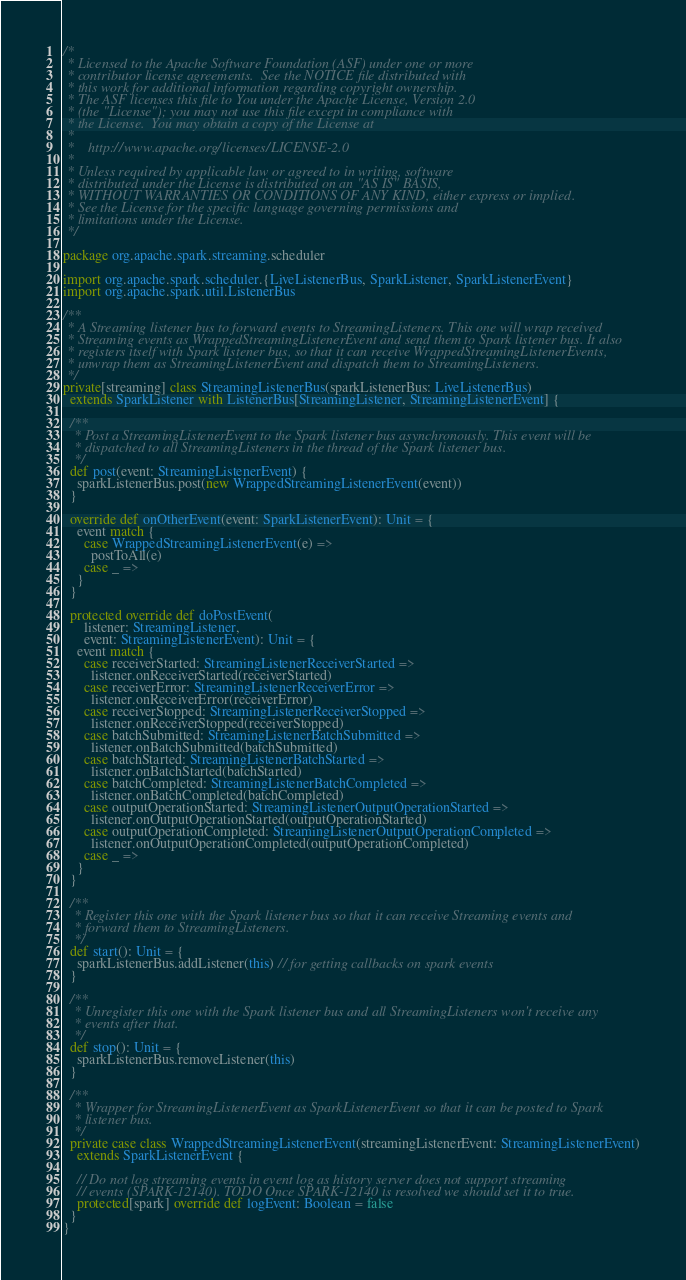Convert code to text. <code><loc_0><loc_0><loc_500><loc_500><_Scala_>/*
 * Licensed to the Apache Software Foundation (ASF) under one or more
 * contributor license agreements.  See the NOTICE file distributed with
 * this work for additional information regarding copyright ownership.
 * The ASF licenses this file to You under the Apache License, Version 2.0
 * (the "License"); you may not use this file except in compliance with
 * the License.  You may obtain a copy of the License at
 *
 *    http://www.apache.org/licenses/LICENSE-2.0
 *
 * Unless required by applicable law or agreed to in writing, software
 * distributed under the License is distributed on an "AS IS" BASIS,
 * WITHOUT WARRANTIES OR CONDITIONS OF ANY KIND, either express or implied.
 * See the License for the specific language governing permissions and
 * limitations under the License.
 */

package org.apache.spark.streaming.scheduler

import org.apache.spark.scheduler.{LiveListenerBus, SparkListener, SparkListenerEvent}
import org.apache.spark.util.ListenerBus

/**
 * A Streaming listener bus to forward events to StreamingListeners. This one will wrap received
 * Streaming events as WrappedStreamingListenerEvent and send them to Spark listener bus. It also
 * registers itself with Spark listener bus, so that it can receive WrappedStreamingListenerEvents,
 * unwrap them as StreamingListenerEvent and dispatch them to StreamingListeners.
 */
private[streaming] class StreamingListenerBus(sparkListenerBus: LiveListenerBus)
  extends SparkListener with ListenerBus[StreamingListener, StreamingListenerEvent] {

  /**
   * Post a StreamingListenerEvent to the Spark listener bus asynchronously. This event will be
   * dispatched to all StreamingListeners in the thread of the Spark listener bus.
   */
  def post(event: StreamingListenerEvent) {
    sparkListenerBus.post(new WrappedStreamingListenerEvent(event))
  }

  override def onOtherEvent(event: SparkListenerEvent): Unit = {
    event match {
      case WrappedStreamingListenerEvent(e) =>
        postToAll(e)
      case _ =>
    }
  }

  protected override def doPostEvent(
      listener: StreamingListener,
      event: StreamingListenerEvent): Unit = {
    event match {
      case receiverStarted: StreamingListenerReceiverStarted =>
        listener.onReceiverStarted(receiverStarted)
      case receiverError: StreamingListenerReceiverError =>
        listener.onReceiverError(receiverError)
      case receiverStopped: StreamingListenerReceiverStopped =>
        listener.onReceiverStopped(receiverStopped)
      case batchSubmitted: StreamingListenerBatchSubmitted =>
        listener.onBatchSubmitted(batchSubmitted)
      case batchStarted: StreamingListenerBatchStarted =>
        listener.onBatchStarted(batchStarted)
      case batchCompleted: StreamingListenerBatchCompleted =>
        listener.onBatchCompleted(batchCompleted)
      case outputOperationStarted: StreamingListenerOutputOperationStarted =>
        listener.onOutputOperationStarted(outputOperationStarted)
      case outputOperationCompleted: StreamingListenerOutputOperationCompleted =>
        listener.onOutputOperationCompleted(outputOperationCompleted)
      case _ =>
    }
  }

  /**
   * Register this one with the Spark listener bus so that it can receive Streaming events and
   * forward them to StreamingListeners.
   */
  def start(): Unit = {
    sparkListenerBus.addListener(this) // for getting callbacks on spark events
  }

  /**
   * Unregister this one with the Spark listener bus and all StreamingListeners won't receive any
   * events after that.
   */
  def stop(): Unit = {
    sparkListenerBus.removeListener(this)
  }

  /**
   * Wrapper for StreamingListenerEvent as SparkListenerEvent so that it can be posted to Spark
   * listener bus.
   */
  private case class WrappedStreamingListenerEvent(streamingListenerEvent: StreamingListenerEvent)
    extends SparkListenerEvent {

    // Do not log streaming events in event log as history server does not support streaming
    // events (SPARK-12140). TODO Once SPARK-12140 is resolved we should set it to true.
    protected[spark] override def logEvent: Boolean = false
  }
}
</code> 